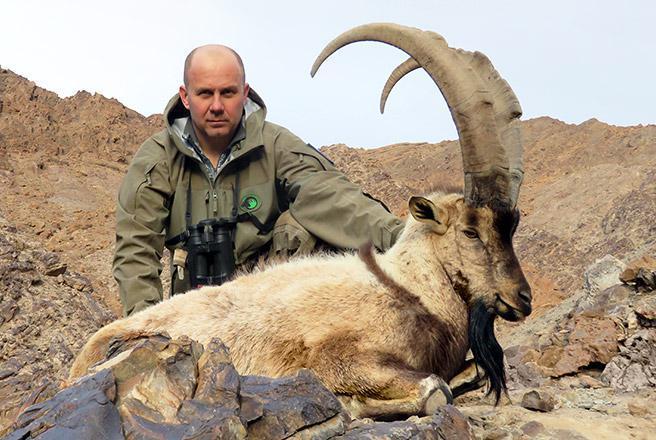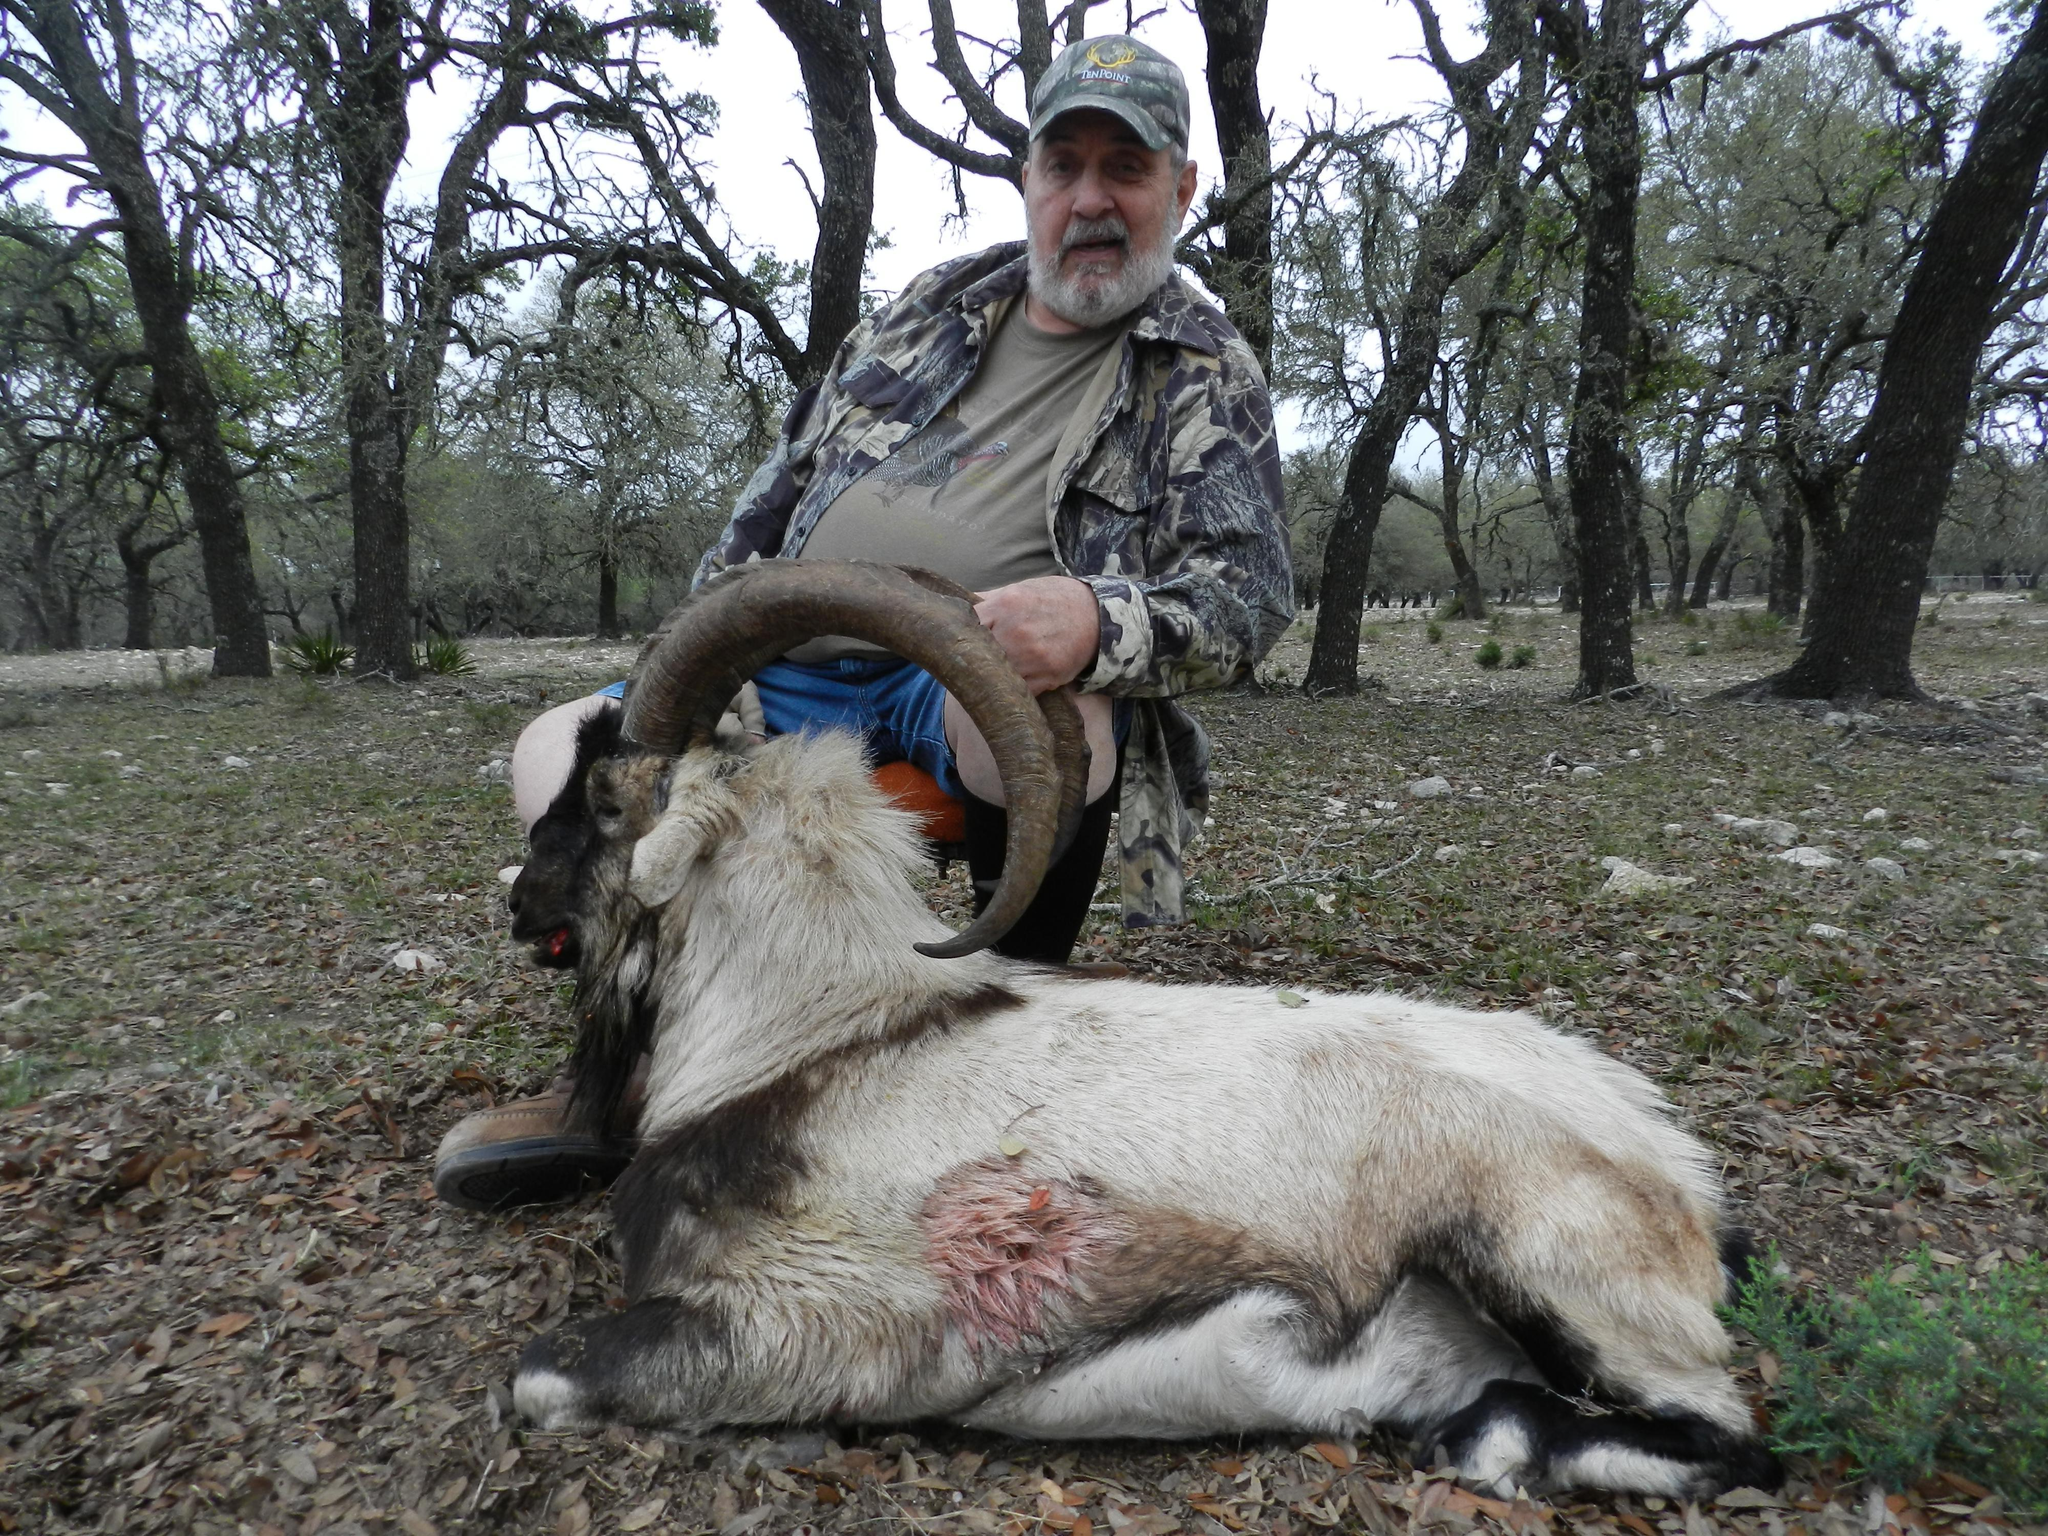The first image is the image on the left, the second image is the image on the right. Examine the images to the left and right. Is the description "The left and right image contains the same number of goats with at least one hunter holding its horns." accurate? Answer yes or no. Yes. 